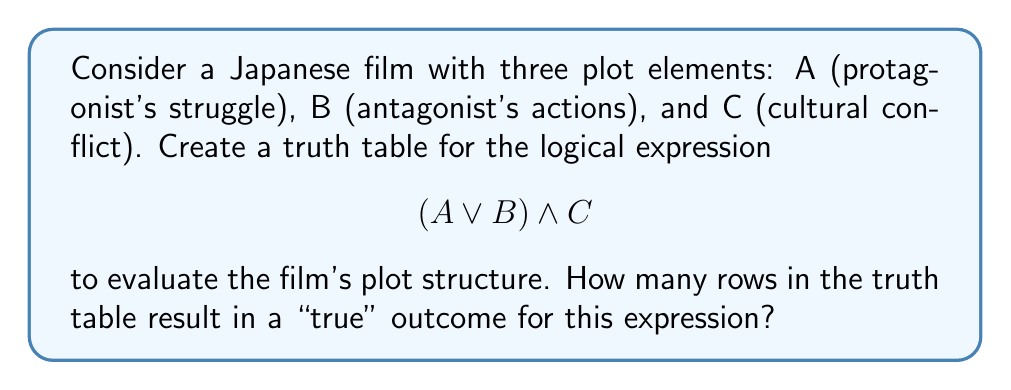Can you solve this math problem? To solve this problem, we'll follow these steps:

1) First, let's create the truth table for the expression $$(A \lor B) \land C$$:

   | A | B | C | A ∨ B | (A ∨ B) ∧ C |
   |---|---|---|-------|-------------|
   | 0 | 0 | 0 |   0   |      0      |
   | 0 | 0 | 1 |   0   |      0      |
   | 0 | 1 | 0 |   1   |      0      |
   | 0 | 1 | 1 |   1   |      1      |
   | 1 | 0 | 0 |   1   |      0      |
   | 1 | 0 | 1 |   1   |      1      |
   | 1 | 1 | 0 |   1   |      0      |
   | 1 | 1 | 1 |   1   |      1      |

2) Now, let's interpret this table in the context of Japanese cinema:
   - A true (1) for A means the protagonist's struggle is significant.
   - A true (1) for B means the antagonist's actions are impactful.
   - A true (1) for C means there's a strong cultural conflict.

3) The expression $$(A \lor B) \land C$$ is true when:
   - At least one of A or B is true (the film has either a strong protagonist struggle or impactful antagonist actions, or both)
   AND
   - C is true (there's a strong cultural conflict)

4) Counting the rows where the final column (A ∨ B) ∧ C is true, we get 3 rows.

This means there are 3 plot structures that satisfy the given logical expression, representing films where cultural conflict interacts with either the protagonist's struggle, the antagonist's actions, or both.
Answer: 3 